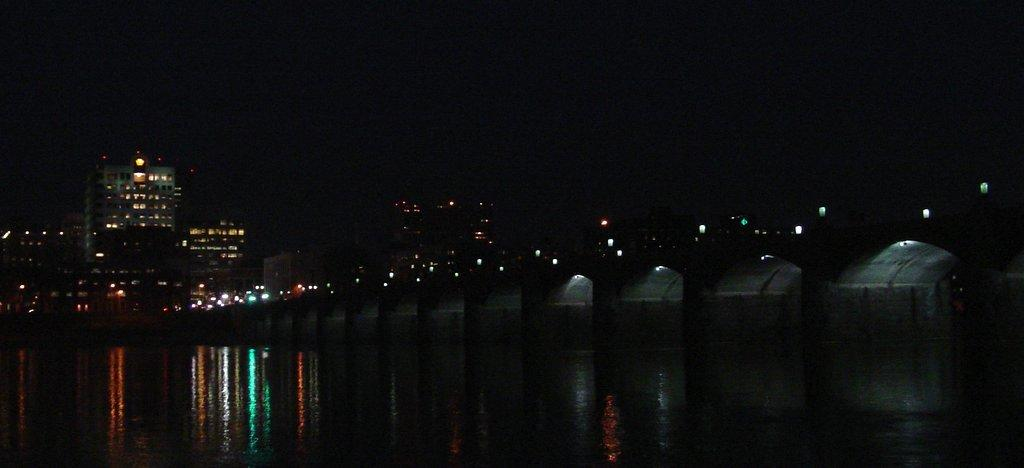What is visible in the image? Water is visible in the image. What can be seen in the background of the image? There are lights and buildings in the background of the image. What is the color of the sky in the image? The sky appears to be black in color. What is the belief of the roof in the image? There is no roof present in the image, so it is not possible to determine any beliefs associated with it. 